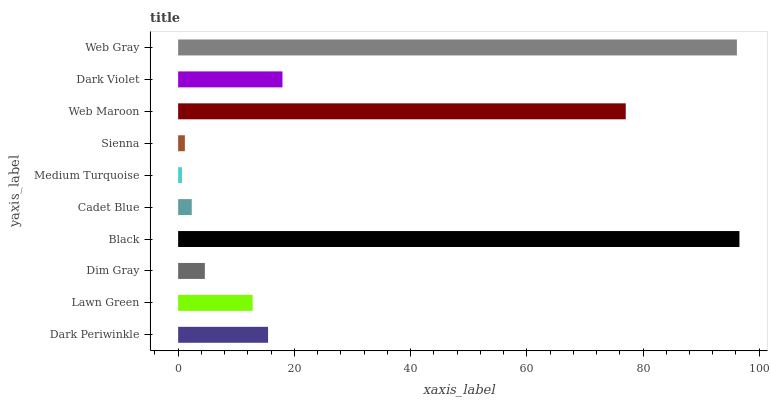Is Medium Turquoise the minimum?
Answer yes or no. Yes. Is Black the maximum?
Answer yes or no. Yes. Is Lawn Green the minimum?
Answer yes or no. No. Is Lawn Green the maximum?
Answer yes or no. No. Is Dark Periwinkle greater than Lawn Green?
Answer yes or no. Yes. Is Lawn Green less than Dark Periwinkle?
Answer yes or no. Yes. Is Lawn Green greater than Dark Periwinkle?
Answer yes or no. No. Is Dark Periwinkle less than Lawn Green?
Answer yes or no. No. Is Dark Periwinkle the high median?
Answer yes or no. Yes. Is Lawn Green the low median?
Answer yes or no. Yes. Is Medium Turquoise the high median?
Answer yes or no. No. Is Dark Periwinkle the low median?
Answer yes or no. No. 